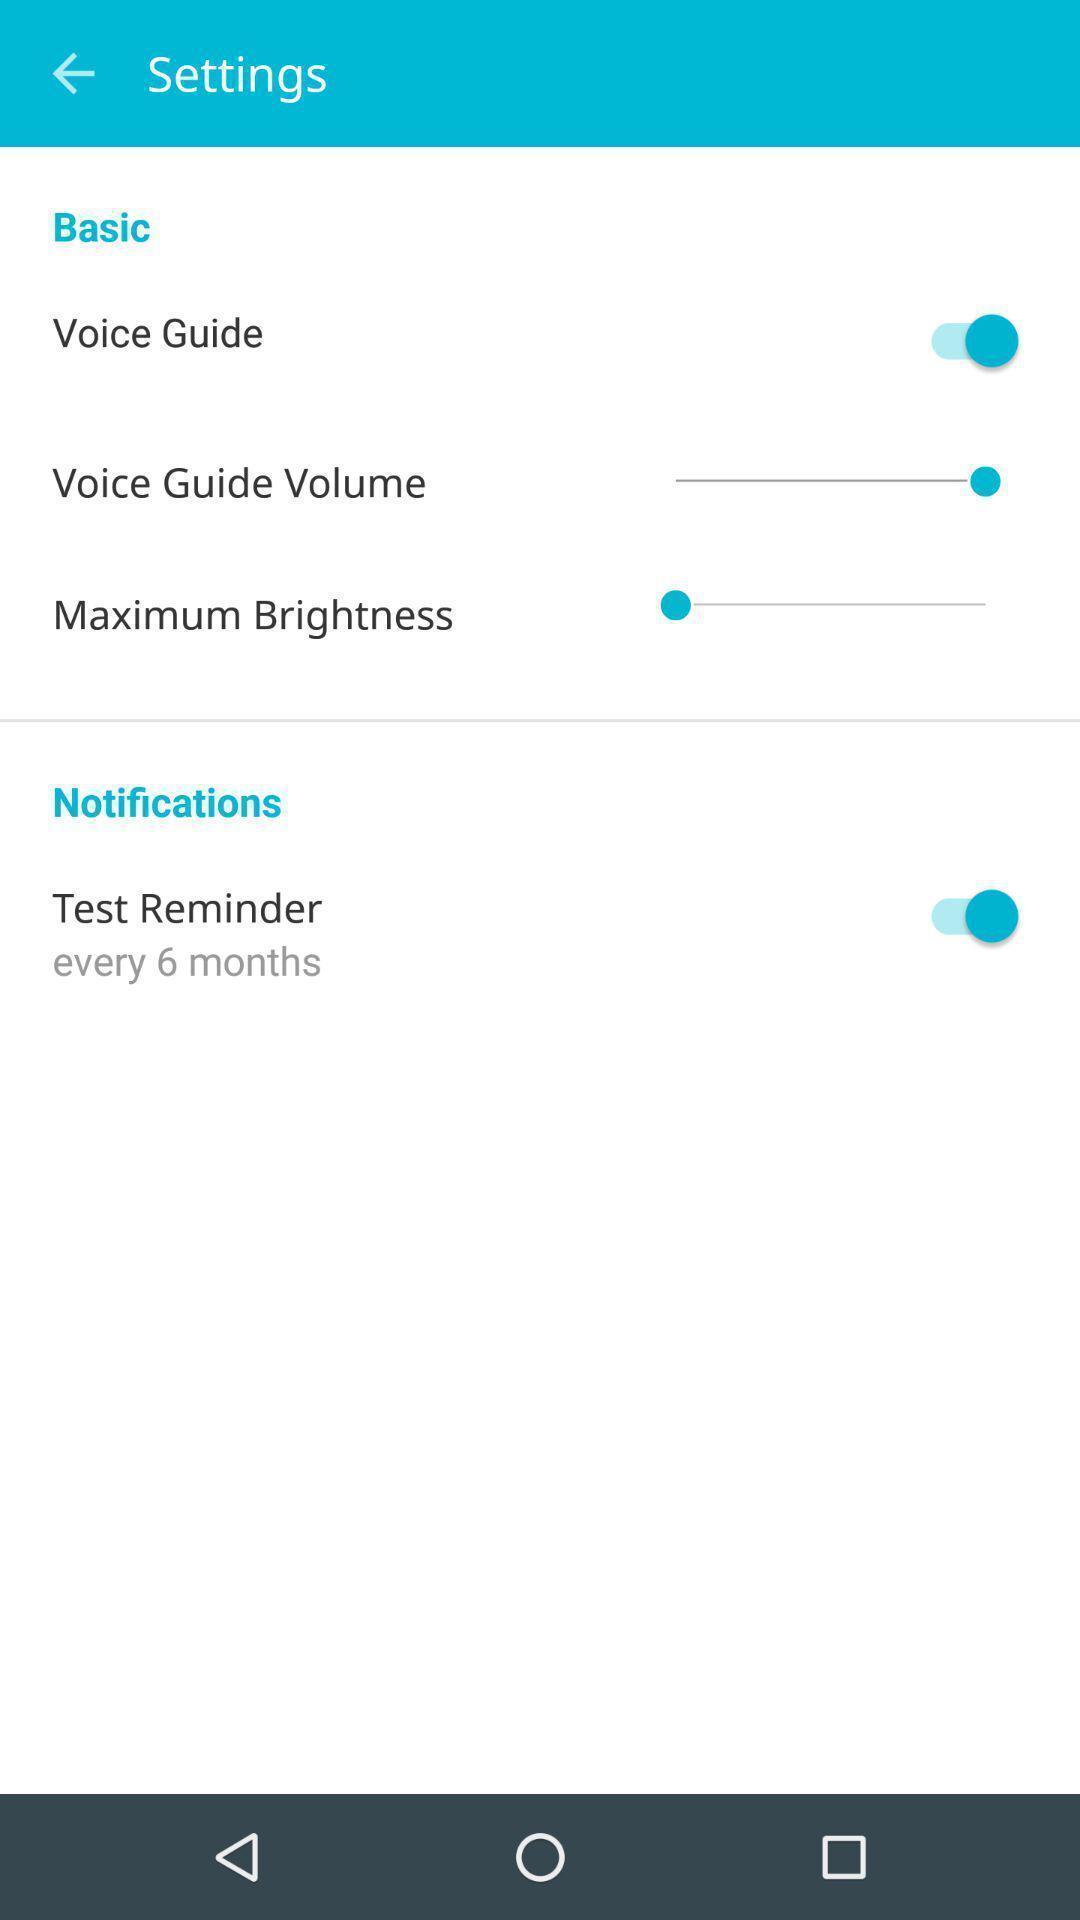Describe the key features of this screenshot. Settings page displayed of a audio app. 